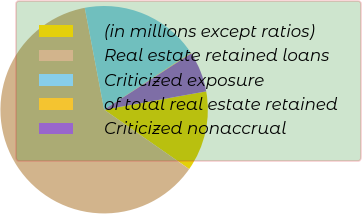Convert chart. <chart><loc_0><loc_0><loc_500><loc_500><pie_chart><fcel>(in millions except ratios)<fcel>Real estate retained loans<fcel>Criticized exposure<fcel>of total real estate retained<fcel>Criticized nonaccrual<nl><fcel>12.53%<fcel>62.31%<fcel>18.76%<fcel>0.09%<fcel>6.31%<nl></chart> 